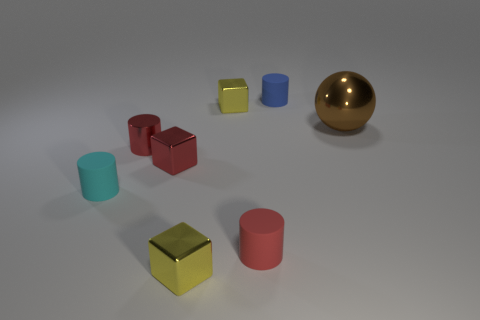Can you describe the arrangement of objects in terms of their colors? Certainly! In the image, I see a variety of colored objects positioned on a flat surface. From left to right, there is a blue cylinder, a small yellow cube, a red cube that appears a bit larger, and another blue cylinder that is smaller. In the background, there's a large shiny gold sphere. 